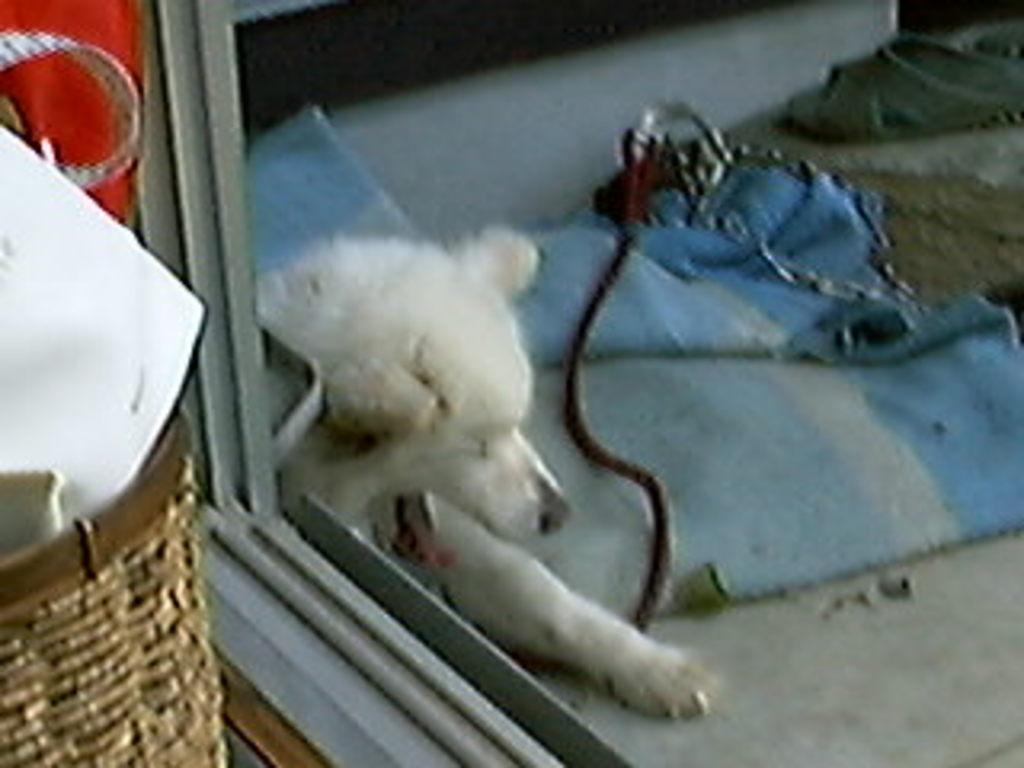Describe this image in one or two sentences. In this picture, we can see a dog, rope and a cloth on the floor. On the left side of the image, it looks like a basket and in the basket there are some objects. At the top right corner of the image, there is a slipper. 